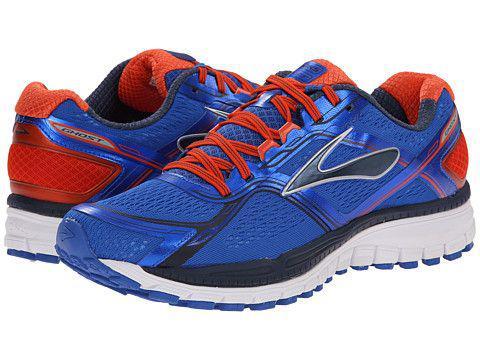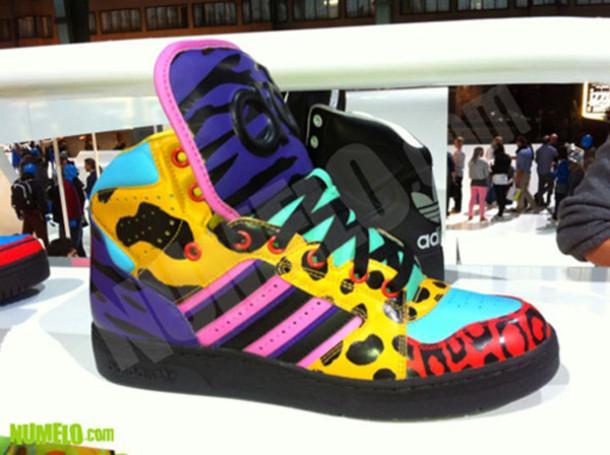The first image is the image on the left, the second image is the image on the right. Given the left and right images, does the statement "1 of the images has 1 shoe facing right in the foreground." hold true? Answer yes or no. Yes. The first image is the image on the left, the second image is the image on the right. For the images shown, is this caption "At least one image shows exactly one pair of shoes." true? Answer yes or no. Yes. 